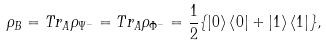Convert formula to latex. <formula><loc_0><loc_0><loc_500><loc_500>\rho _ { B } = T r _ { A } \rho _ { \Psi ^ { - } } = T r _ { A } \rho _ { \Phi ^ { - } } = \frac { 1 } { 2 } \{ \left | 0 \right \rangle \left \langle 0 \right | + \left | 1 \right \rangle \left \langle 1 \right | \} ,</formula> 